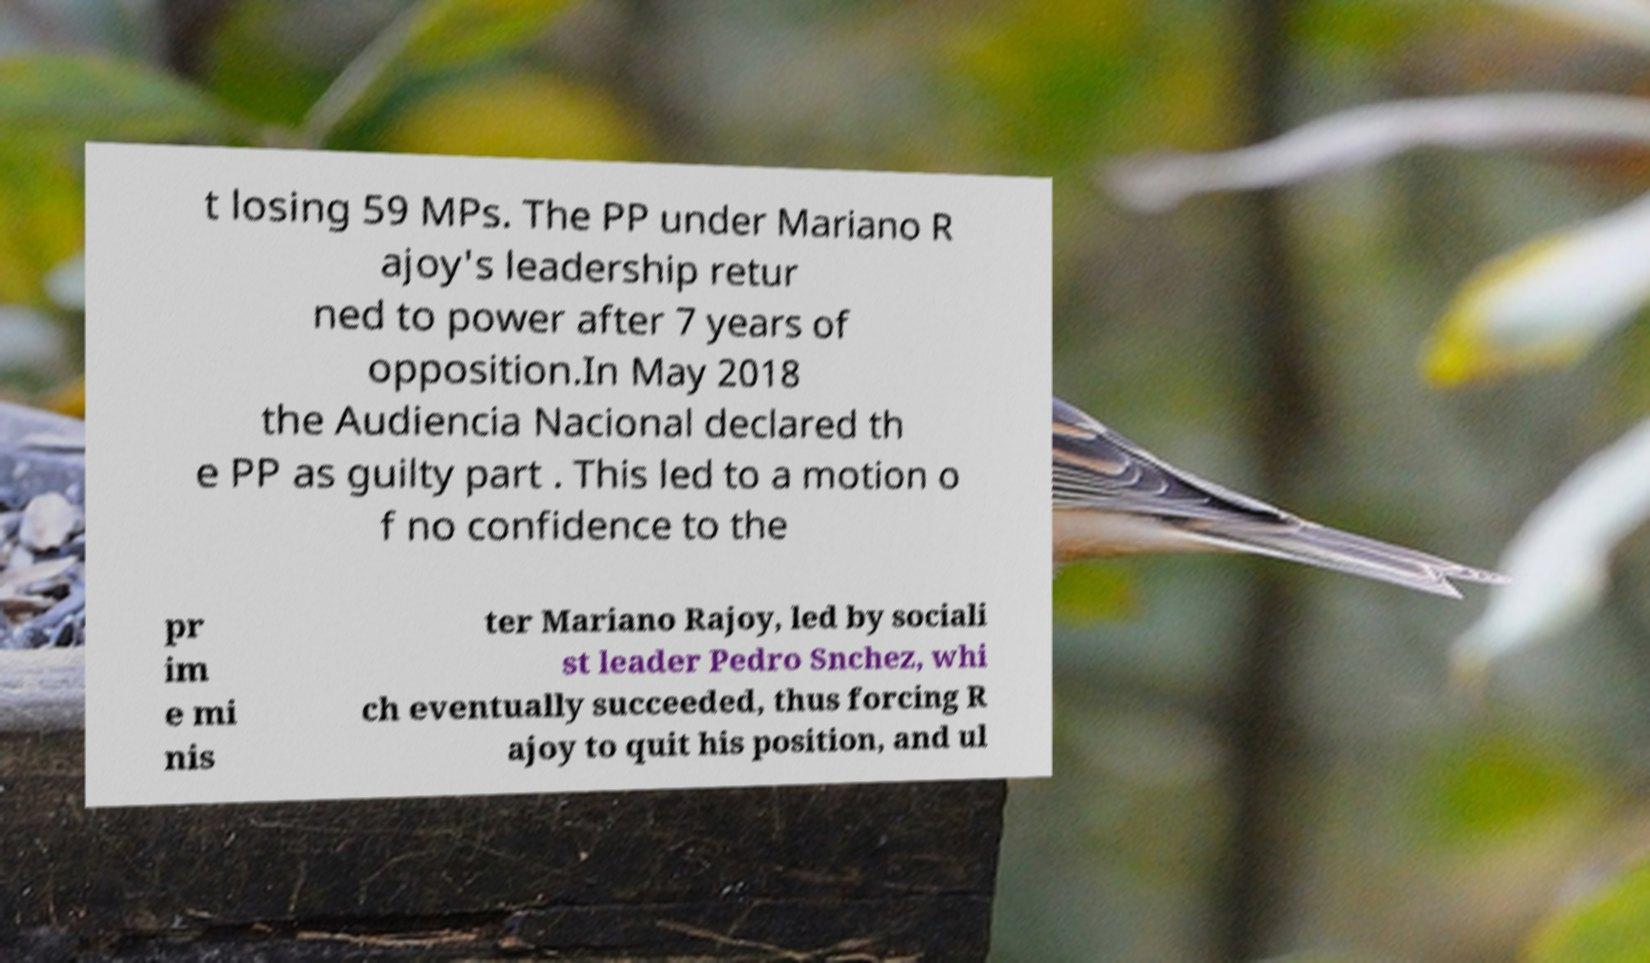Could you assist in decoding the text presented in this image and type it out clearly? t losing 59 MPs. The PP under Mariano R ajoy's leadership retur ned to power after 7 years of opposition.In May 2018 the Audiencia Nacional declared th e PP as guilty part . This led to a motion o f no confidence to the pr im e mi nis ter Mariano Rajoy, led by sociali st leader Pedro Snchez, whi ch eventually succeeded, thus forcing R ajoy to quit his position, and ul 